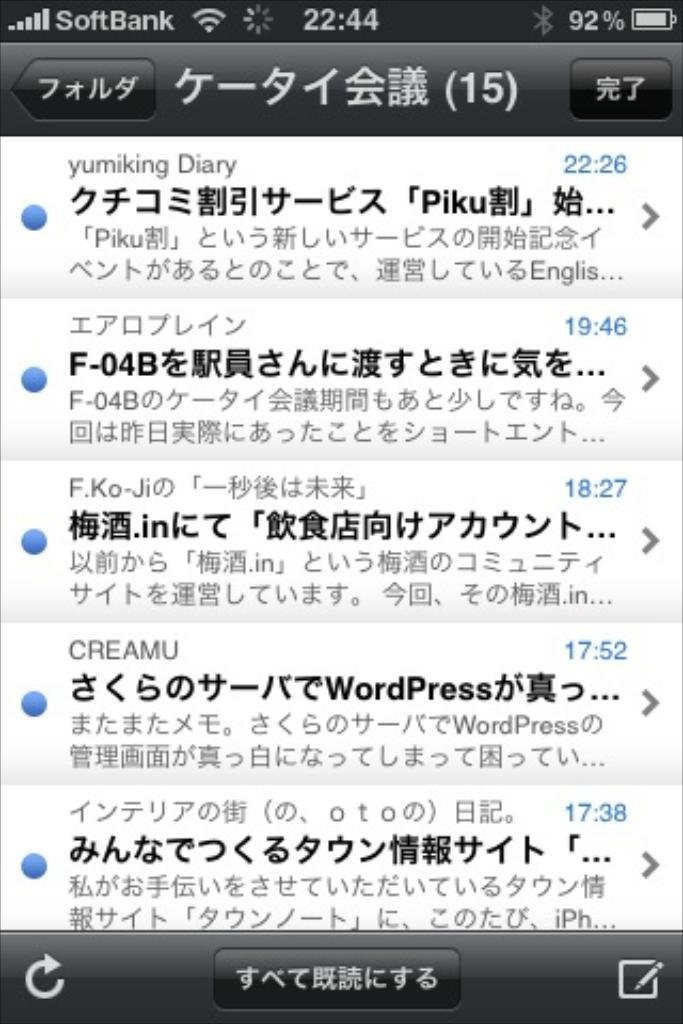Provide a one-sentence caption for the provided image. The screenshot from a phone are texts or emails in a foreign language. 